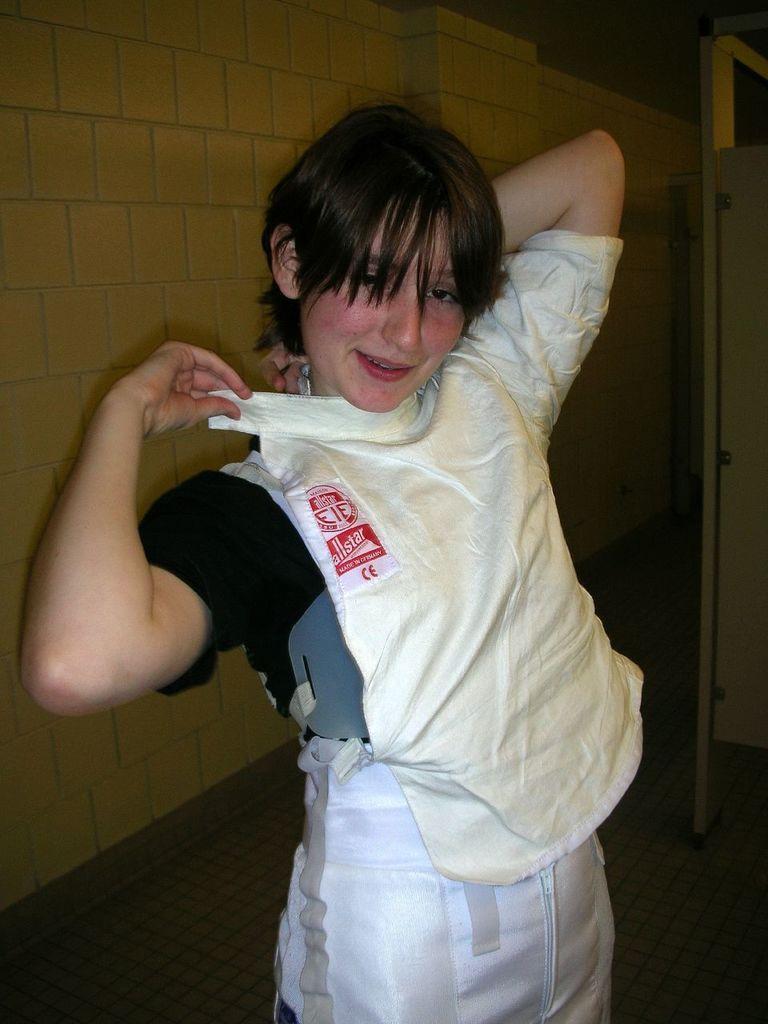How would you summarize this image in a sentence or two? In this image I can see a woman standing and is wearing a top and posing for the picture. I can see a wall behind her. The background is dark. 